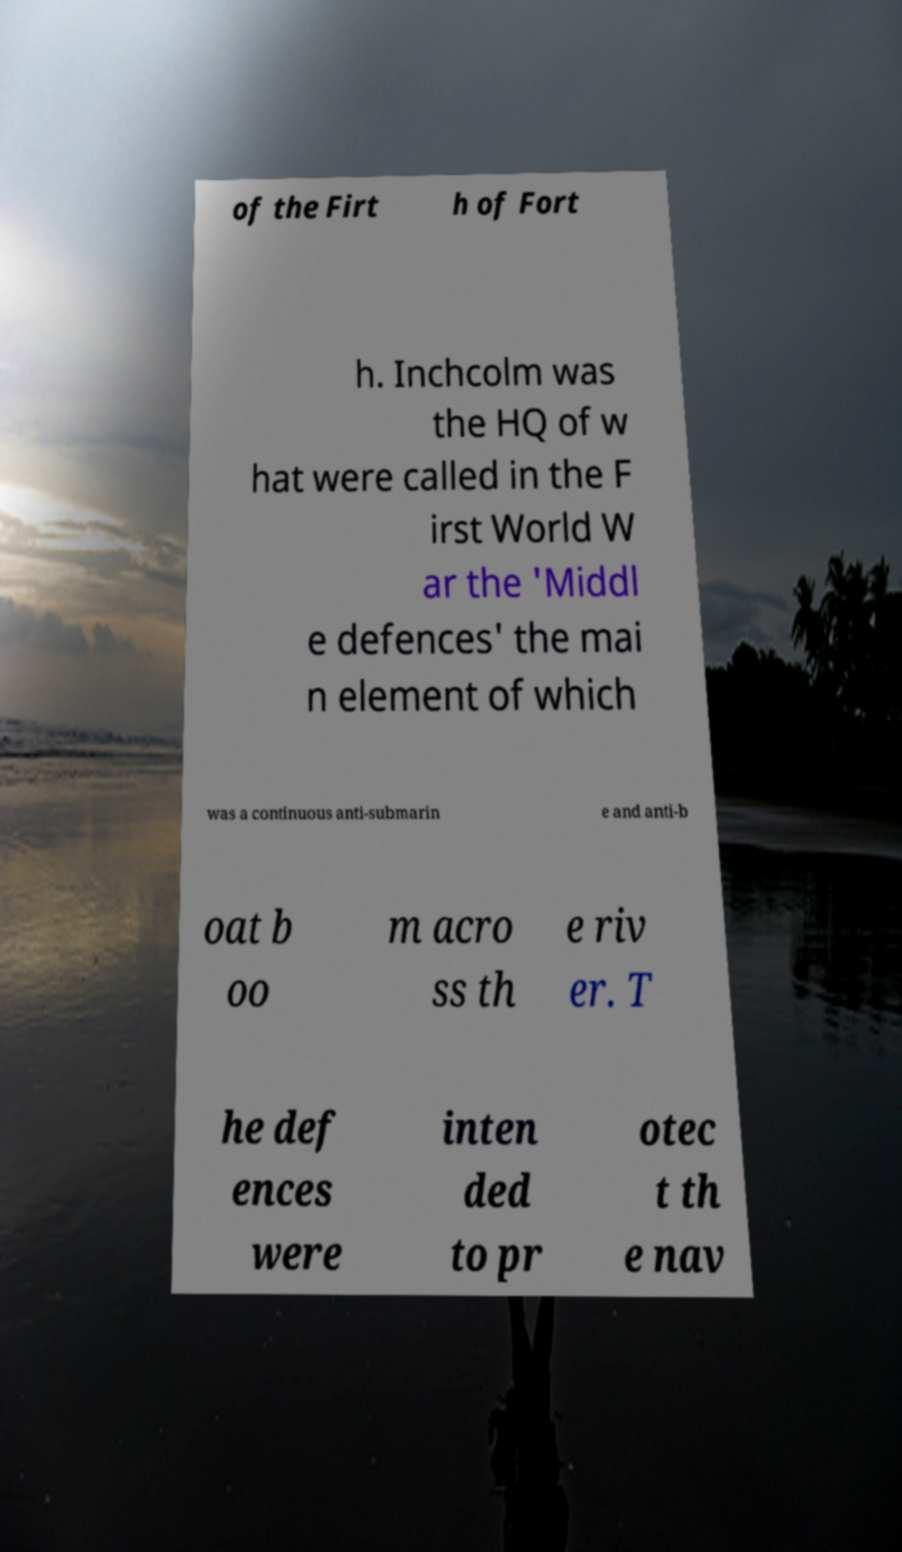Can you accurately transcribe the text from the provided image for me? of the Firt h of Fort h. Inchcolm was the HQ of w hat were called in the F irst World W ar the 'Middl e defences' the mai n element of which was a continuous anti-submarin e and anti-b oat b oo m acro ss th e riv er. T he def ences were inten ded to pr otec t th e nav 